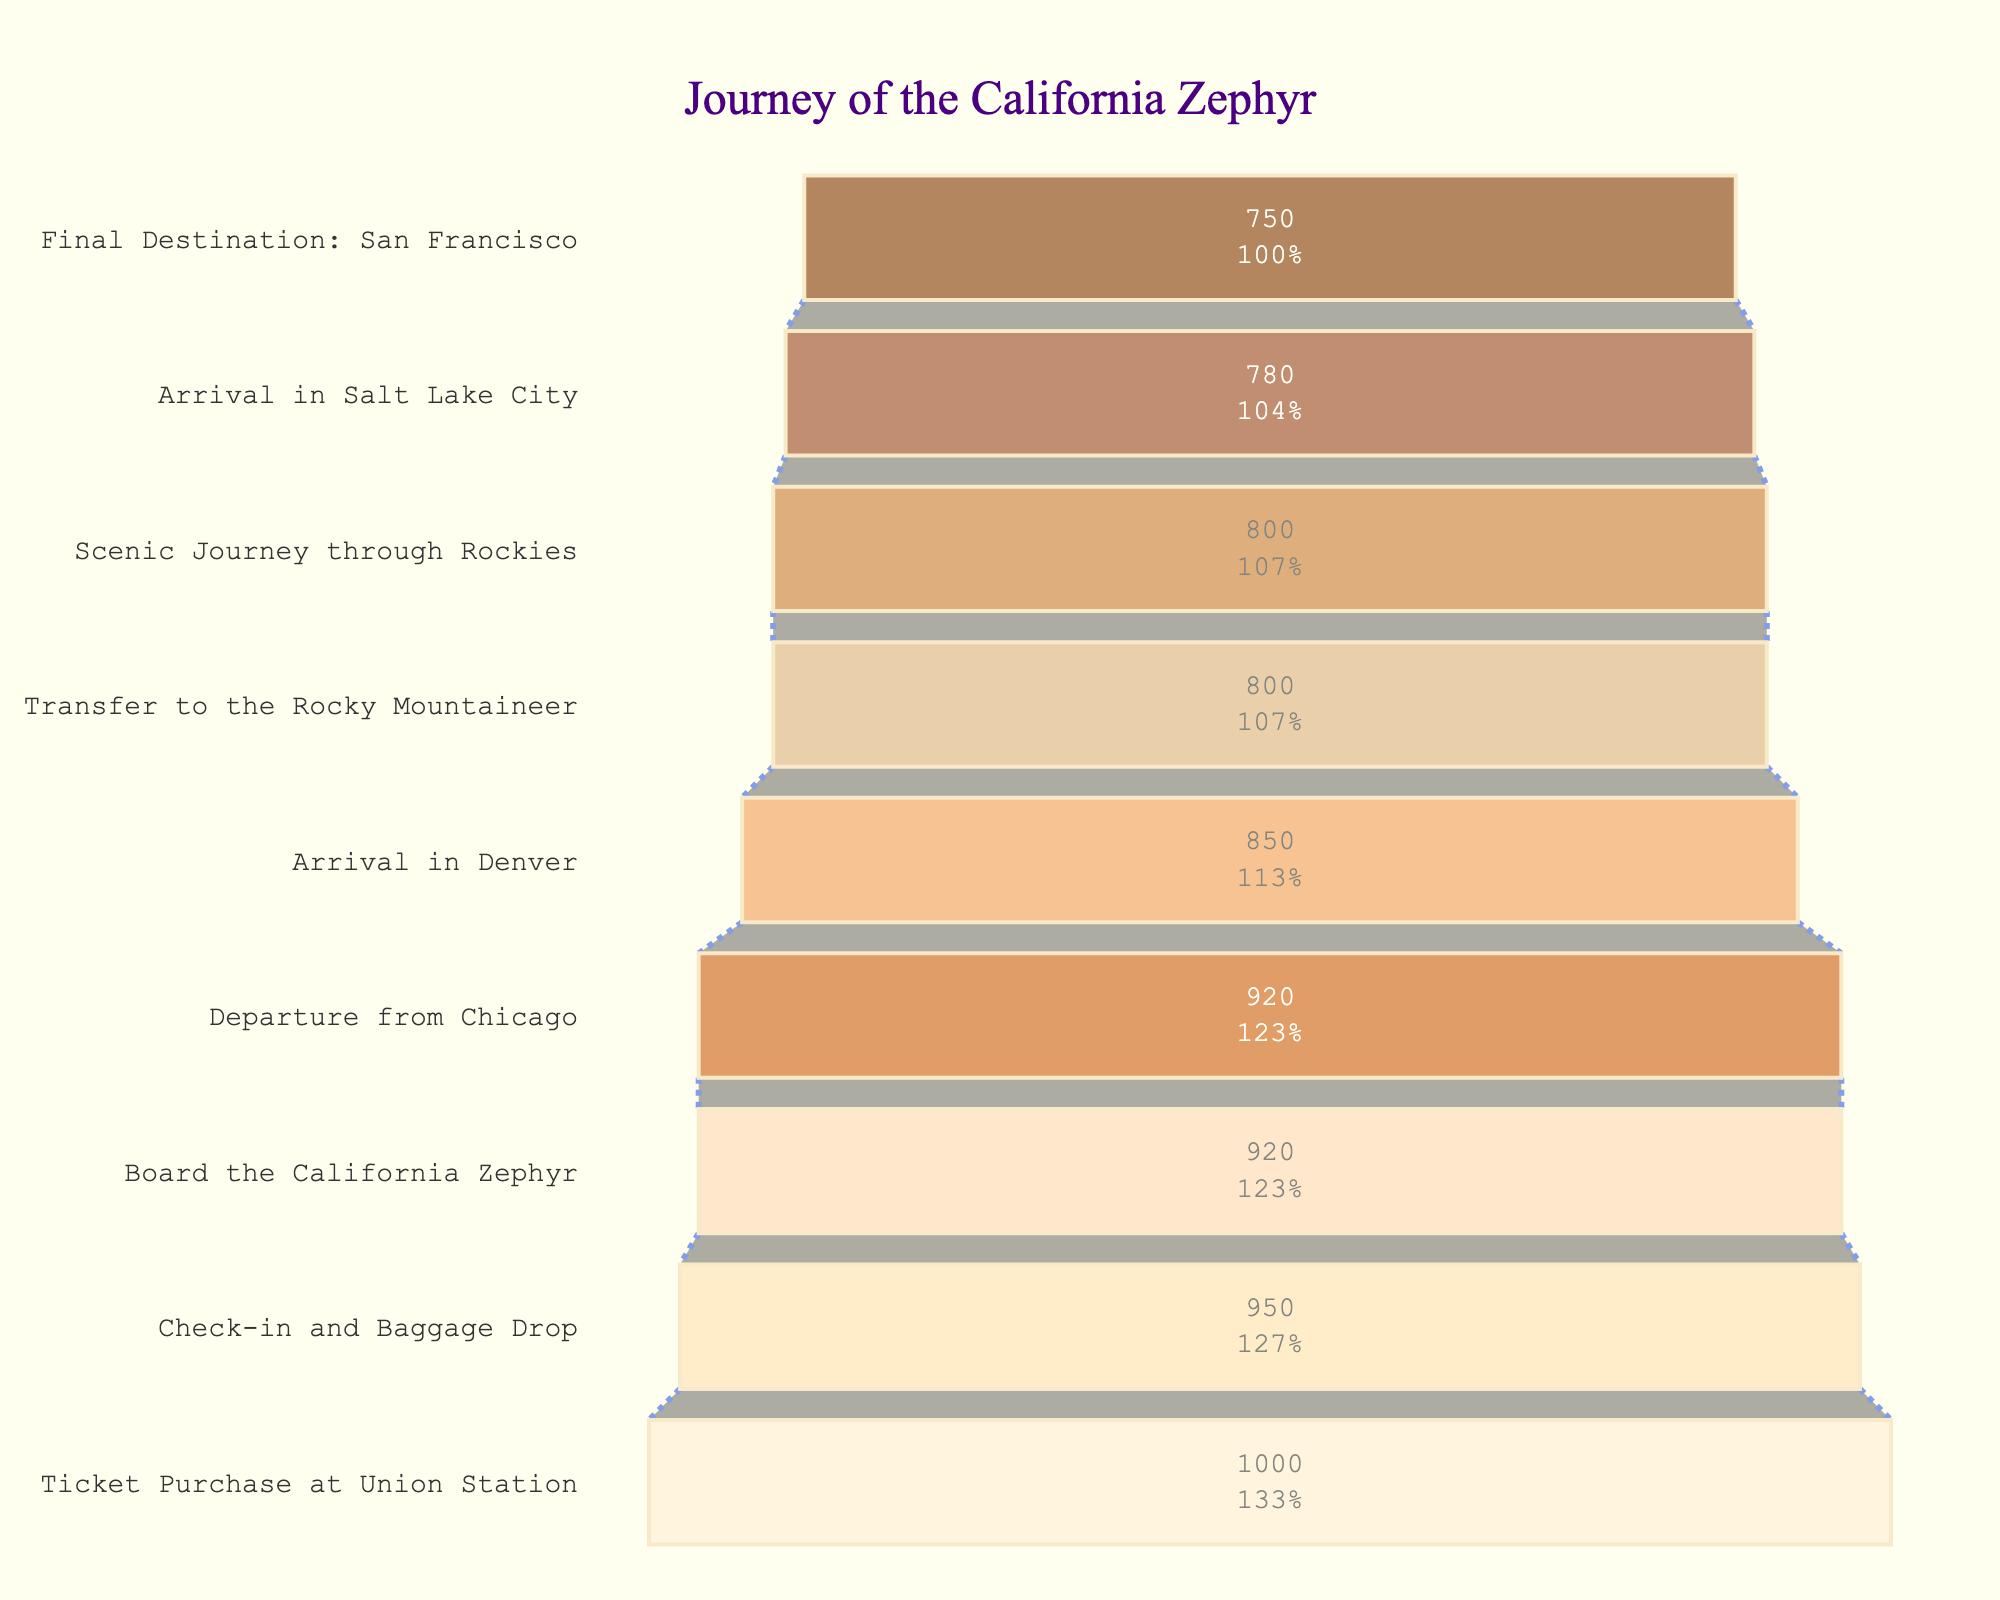What's the title of the funnel chart? The title of the chart is usually placed at the top and clearly indicates the subject of the figure.
Answer: Journey of the California Zephyr How many passengers started the journey at Union Station? This information is found in the first stage of the funnel chart.
Answer: 1000 How many passengers completed the journey to the final destination? The final stage of the funnel chart displays the number of passengers who reached San Francisco.
Answer: 750 What percentage of passengers who started the journey at Union Station reached the final destination in San Francisco? To find the percentage, take the number of passengers who reached the final destination (750) and divide by the initial number of passengers (1000), then multiply by 100. 750/1000 * 100 = 75%.
Answer: 75% Which stage had the largest drop in passenger numbers? Compare the number of passengers between successive stages to identify the largest decrease. The largest drop is from "Departure from Chicago" (920) to "Arrival in Denver" (850).
Answer: Arrival in Denver How many passengers ended their journey at Denver? This stage is clearly marked in the funnel chart.
Answer: 850 What's the difference in the number of passengers between Check-in and Baggage Drop and Departure from Chicago? Subtract the number of passengers at Departure from Chicago (920) from Check-in and Baggage Drop (950). 950 - 920 = 30.
Answer: 30 What is the average number of passengers across all stages? To find the average, sum up the passengers at each stage and divide by the number of stages. (1000 + 950 + 920 + 920 + 850 + 800 + 800 + 780 + 750) / 9. Sum is 7770, so average is 7770 / 9 ≈ 863.33.
Answer: 863.33 How many stages involve a transfer? Count the stages in the chart that mention a transfer. Only one stage mentions a transfer, "Transfer to the Rocky Mountaineer".
Answer: 1 Which stage immediately follows the scenic journey through the Rockies? The stage immediately after "Scenic Journey through Rockies" is "Arrival in Salt Lake City".
Answer: Arrival in Salt Lake City 